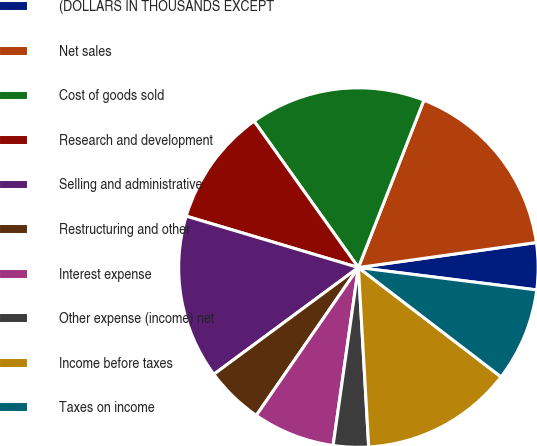Convert chart to OTSL. <chart><loc_0><loc_0><loc_500><loc_500><pie_chart><fcel>(DOLLARS IN THOUSANDS EXCEPT<fcel>Net sales<fcel>Cost of goods sold<fcel>Research and development<fcel>Selling and administrative<fcel>Restructuring and other<fcel>Interest expense<fcel>Other expense (income) net<fcel>Income before taxes<fcel>Taxes on income<nl><fcel>4.21%<fcel>16.84%<fcel>15.79%<fcel>10.53%<fcel>14.74%<fcel>5.26%<fcel>7.37%<fcel>3.16%<fcel>13.68%<fcel>8.42%<nl></chart> 